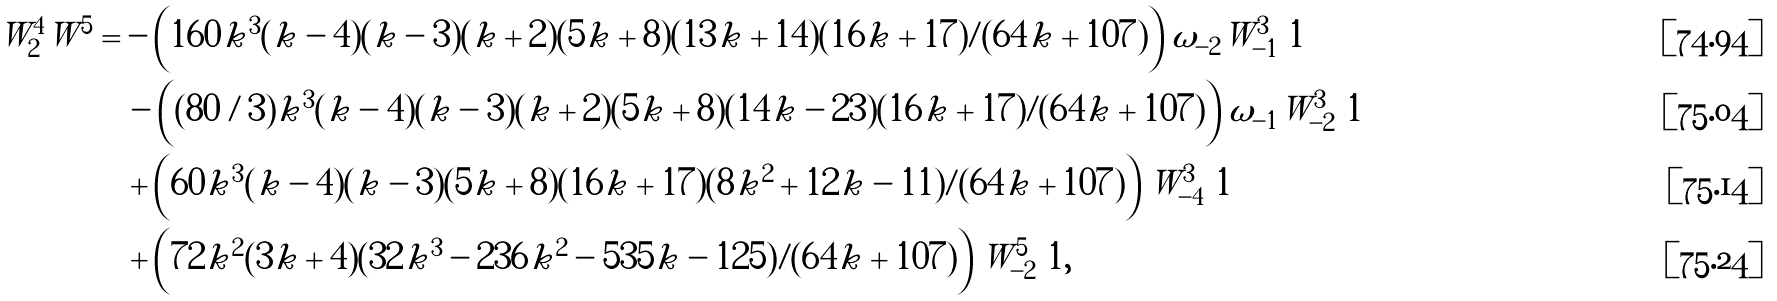<formula> <loc_0><loc_0><loc_500><loc_500>W ^ { 4 } _ { 2 } W ^ { 5 } & = - \left ( 1 6 0 k ^ { 3 } ( k - 4 ) ( k - 3 ) ( k + 2 ) ( 5 k + 8 ) ( 1 3 k + 1 4 ) ( 1 6 k + 1 7 ) / ( 6 4 k + 1 0 7 ) \right ) \omega _ { - 2 } W ^ { 3 } _ { - 1 } \ 1 \\ & \quad - \left ( ( 8 0 / 3 ) k ^ { 3 } ( k - 4 ) ( k - 3 ) ( k + 2 ) ( 5 k + 8 ) ( 1 4 k - 2 3 ) ( 1 6 k + 1 7 ) / ( 6 4 k + 1 0 7 ) \right ) \omega _ { - 1 } W ^ { 3 } _ { - 2 } \ 1 \\ & \quad + \left ( 6 0 k ^ { 3 } ( k - 4 ) ( k - 3 ) ( 5 k + 8 ) ( 1 6 k + 1 7 ) ( 8 k ^ { 2 } + 1 2 k - 1 1 ) / ( 6 4 k + 1 0 7 ) \right ) W ^ { 3 } _ { - 4 } \ 1 \\ & \quad + \left ( 7 2 k ^ { 2 } ( 3 k + 4 ) ( 3 2 k ^ { 3 } - 2 3 6 k ^ { 2 } - 5 3 5 k - 1 2 5 ) / ( 6 4 k + 1 0 7 ) \right ) W ^ { 5 } _ { - 2 } \ 1 ,</formula> 